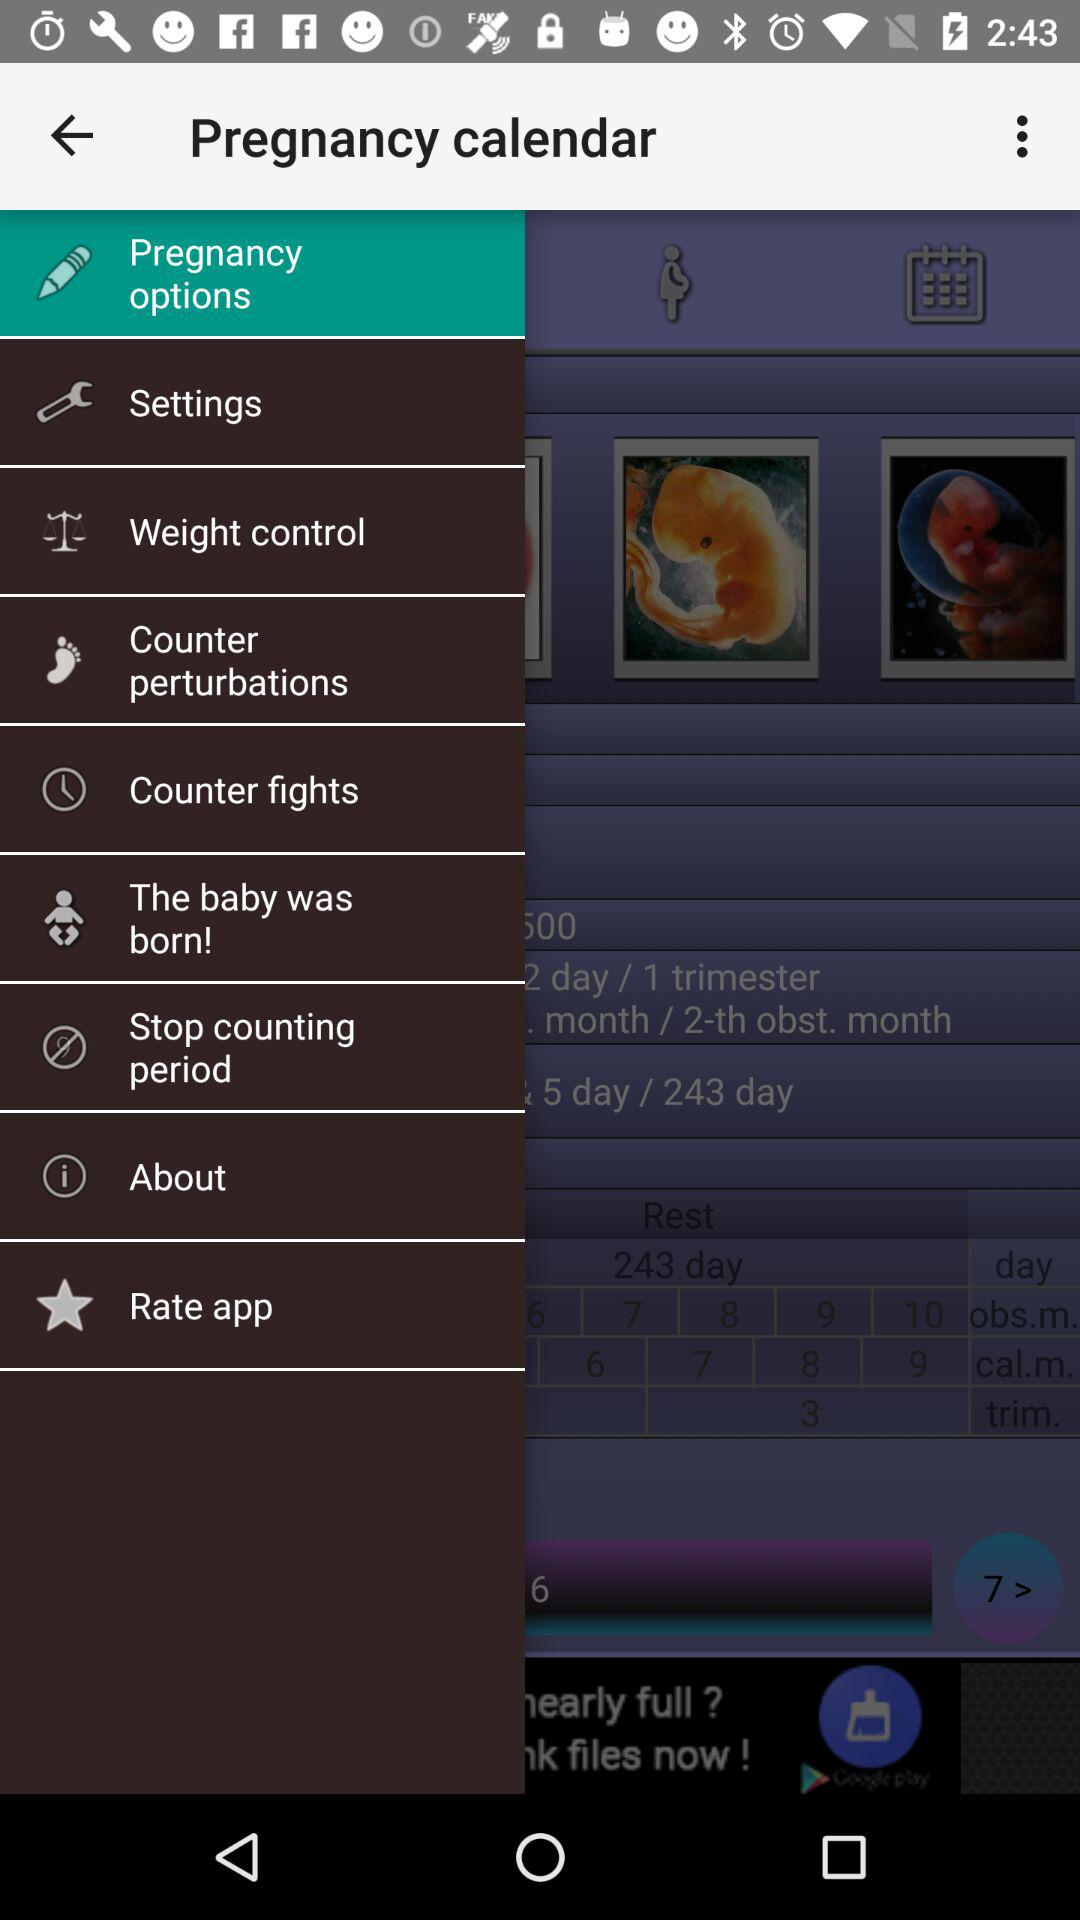What is the selected option? The selected option is "Pregnancy options". 